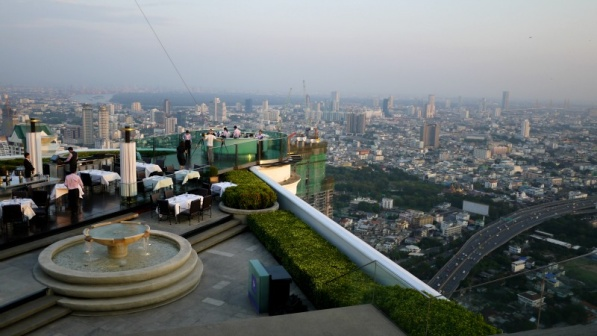Analyze the image in a comprehensive and detailed manner. The image showcases a vibrant rooftop bar perched on the edge of a high-rise building, offering a stunning panoramic view of a sprawling cityscape below. Enclosed by a green railing for safety, the bar boasts a series of white umbrellas that provide elegant shade for patrons. The seating arrangements include numerous tables and chairs thoughtfully positioned to ensure comfort and unobstructed views of the breathtaking cityscape. A fountain in the foreground adds an element of serenity, enhancing the tranquil atmosphere amidst the urban backdrop. The city below is a mosaic of densely packed buildings and winding roads, reflecting a lively, bustling metropolis. The architectural diversity hints at the rich cultural and historical tapestry of the city. The slightly hazy sky suggests environmental challenges like pollution. Even without visible people, the image evokes a sensory experience, conjuring sounds of clinking glasses, murmured conversations, and soft background music, composing the quintessential ambiance of an evening out in the city. 